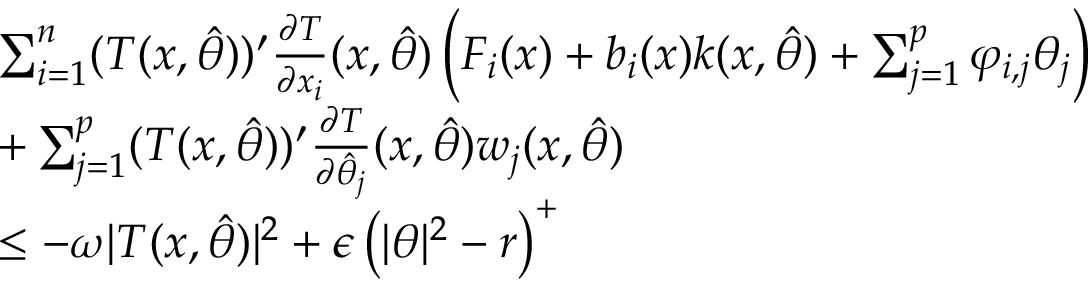Convert formula to latex. <formula><loc_0><loc_0><loc_500><loc_500>\begin{array} { r l } & { \sum _ { i = 1 } ^ { n } ( T ( x , \hat { \theta } ) ) ^ { \prime } \frac { \partial T } { \partial x _ { i } } ( x , \hat { \theta } ) \left ( F _ { i } ( x ) + b _ { i } ( x ) k ( x , \hat { \theta } ) + \sum _ { j = 1 } ^ { p } \varphi _ { i , j } \theta _ { j } \right ) } \\ & { + \sum _ { j = 1 } ^ { p } ( T ( x , \hat { \theta } ) ) ^ { \prime } \frac { \partial T } { \partial \hat { \theta } _ { j } } ( x , \hat { \theta } ) w _ { j } ( x , \hat { \theta } ) } \\ & { \leq - \omega | T ( x , \hat { \theta } ) | ^ { 2 } + \epsilon \left ( | \theta | ^ { 2 } - r \right ) ^ { + } } \end{array}</formula> 